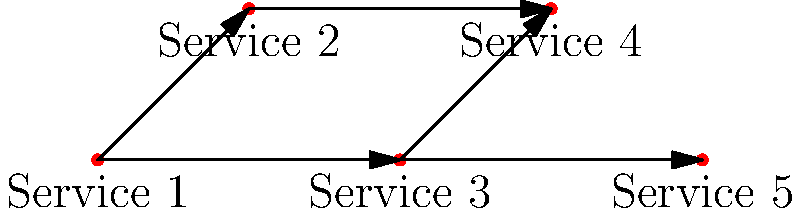Given the directed graph representing container dependencies in a Docker-compose file, how many services have no outgoing dependencies (i.e., are not depended upon by any other service)? To solve this problem, we need to analyze the directed graph and count the number of vertices (services) that have no outgoing edges. Let's go through the process step-by-step:

1. Identify all vertices in the graph:
   - There are 5 vertices, representing Services 1, 2, 3, 4, and 5.

2. Analyze the edges (dependencies) for each vertex:
   - Service 1 has two outgoing edges (to Services 2 and 3)
   - Service 2 has one outgoing edge (to Service 4)
   - Service 3 has two outgoing edges (to Services 4 and 5)
   - Service 4 has no outgoing edges
   - Service 5 has no outgoing edges

3. Count the number of vertices with no outgoing edges:
   - Service 4 and Service 5 have no outgoing edges

4. Calculate the final count:
   - There are 2 services with no outgoing dependencies

Therefore, in this Docker-compose dependency graph, there are 2 services that have no outgoing dependencies, meaning they are not depended upon by any other service.
Answer: 2 